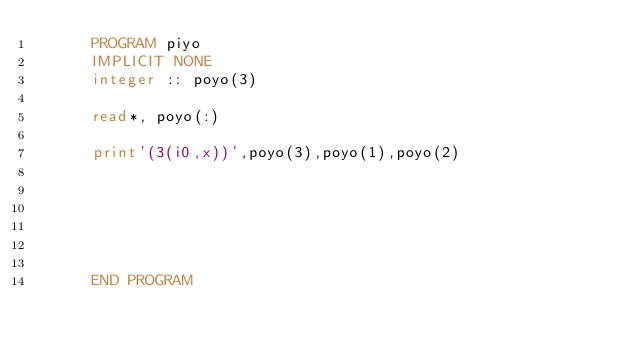Convert code to text. <code><loc_0><loc_0><loc_500><loc_500><_FORTRAN_>      PROGRAM piyo
      IMPLICIT NONE
      integer :: poyo(3)
      
      read*, poyo(:)
      
      print'(3(i0,x))',poyo(3),poyo(1),poyo(2)
      
      
      
      
      
      
      END PROGRAM</code> 